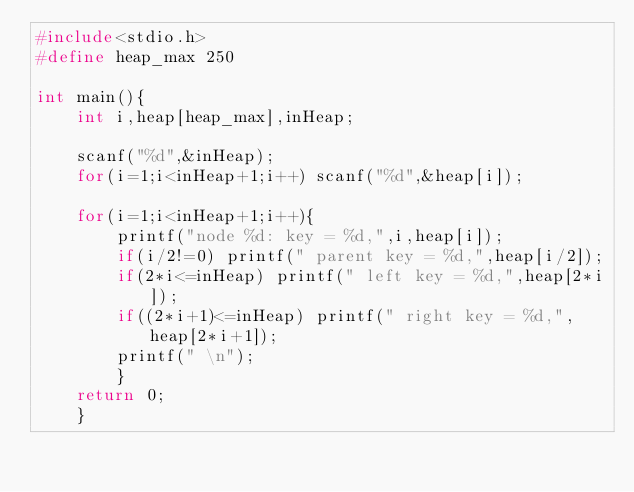<code> <loc_0><loc_0><loc_500><loc_500><_C_>#include<stdio.h>
#define heap_max 250
     
int main(){
    int i,heap[heap_max],inHeap;
     
    scanf("%d",&inHeap);
    for(i=1;i<inHeap+1;i++) scanf("%d",&heap[i]);
     
    for(i=1;i<inHeap+1;i++){
        printf("node %d: key = %d,",i,heap[i]);
        if(i/2!=0) printf(" parent key = %d,",heap[i/2]);
        if(2*i<=inHeap) printf(" left key = %d,",heap[2*i]);
        if((2*i+1)<=inHeap) printf(" right key = %d,",heap[2*i+1]);
        printf(" \n");
        }
    return 0;
    }</code> 